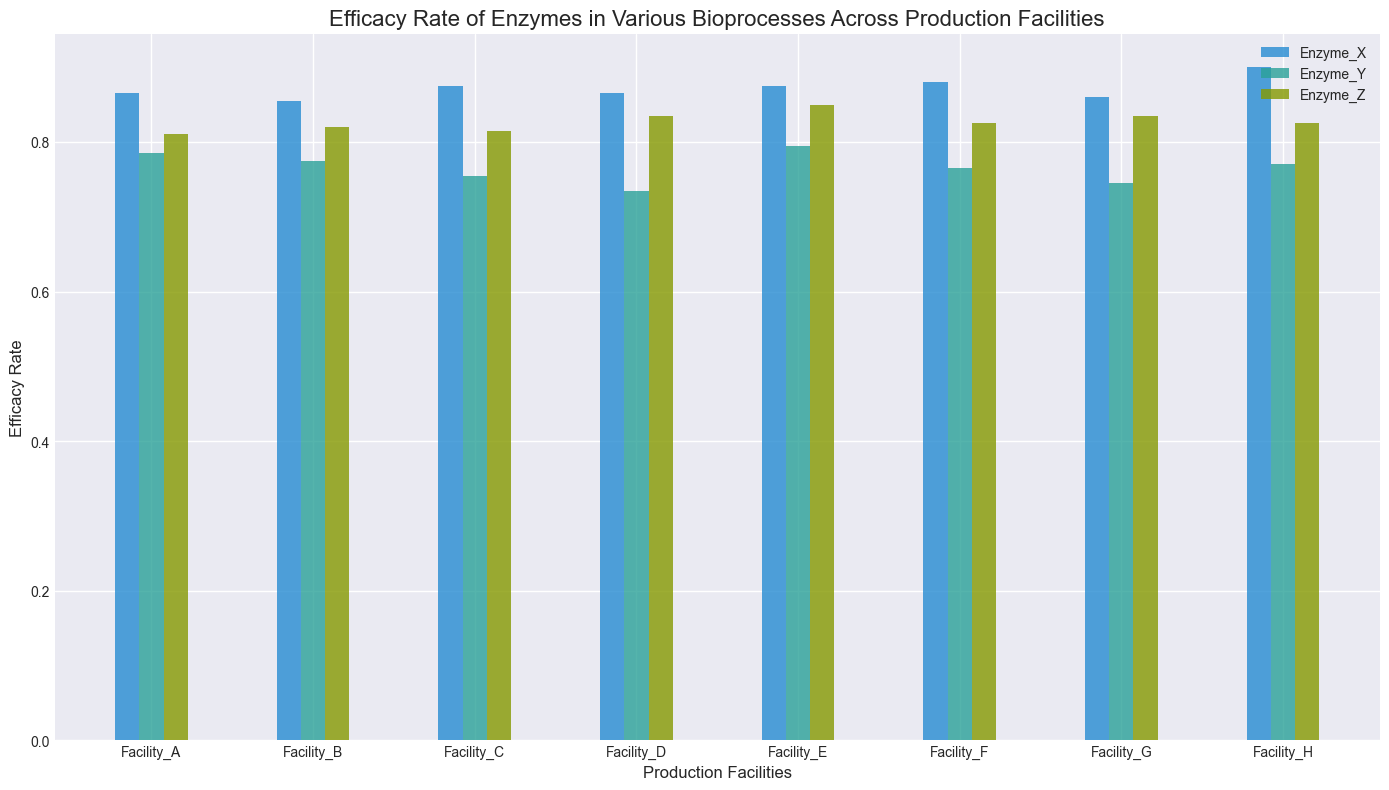What is the enzyme with the highest efficacy rate in Facility_H? First, identify Facility_H's data. Look at the bars for Facility_H and find the bar that represents the highest value. Enzyme_X in both Process_1 and Process_2 are taller than other enzymes. Their average efficacy rate is the highest when compared to Enzyme_Y and Enzyme_Z.
Answer: Enzyme_X Which production facility has the lowest efficacy rate for Enzyme_Y in Process_2? Identify the bars representing each facility's efficacy rate for Enzyme_Y in Process_2. Facility_D has the shortest bar for Enzyme_Y in Process_2.
Answer: Facility_D For Facility_D, how much higher is the efficacy rate of Enzyme_X in Process_2 compared to Enzyme_Y in Process_2? Find and compare the heights of the bars for Enzyme_X and Enzyme_Y in Process_2 for Facility_D. Enzyme_X in Process_2 has an efficacy rate of 0.90 and Enzyme_Y has 0.73. Calculate the difference: 0.90 - 0.73 = 0.17.
Answer: 0.17 Which enzyme has the most consistent efficacy rates across all facilities for Process_1? Observe the heights of the bars for each enzyme across all facilities in Process_1. Enzyme_X bars appear the most consistent in height when compared to Enzyme_Y and Enzyme_Z.
Answer: Enzyme_X What is the average efficacy rate of Enzyme_Z across all production facilities in Process_2? Identify the efficacy rates for Enzyme_Z in Process_2 across all facilities, sum them up and then divide by the number of facilities (8). The values are 0.82, 0.83, 0.84, 0.85, 0.86, 0.87, 0.86, 0.83. Their sum is 6.76 and the average is 6.76 / 8 = 0.845.
Answer: 0.845 Which bioprocess, on average, shows a higher efficacy rate for enzymes in Facility_G? Compare the average heights of bars for all enzymes in Process_1 and Process_2 for Facility_G. The bars in Process_2 appear higher.
Answer: Process_2 Does Enzyme_Y tend to have higher or lower efficacy rates compared to other enzymes? Compare the typical heights of Enzyme_Y bars with those of Enzyme_X and Enzyme_Z across all facilities and processes. Enzyme_Y bars generally tend to be lower than those for Enzyme_X and Enzyme_Z.
Answer: Lower For Facility_C, what is the difference in efficacy rates of Enzyme_Z between Process_1 and Process_2? Identify the efficacy rates for Enzyme_Z in Process_1 and Process_2 for Facility_C. Process_1 is 0.79, and Process_2 is 0.84. Calculate the difference: 0.84 - 0.79 = 0.05.
Answer: 0.05 Which facility shows the smallest range of efficacy rates for all enzymes across both processes? Determine the range by subtracting the minimum efficacy rate from the maximum efficacy rate for each facility. Compare the ranges, Facility_E has the smallest range since its coverage looks even without drastic highs or lows.
Answer: Facility_E 